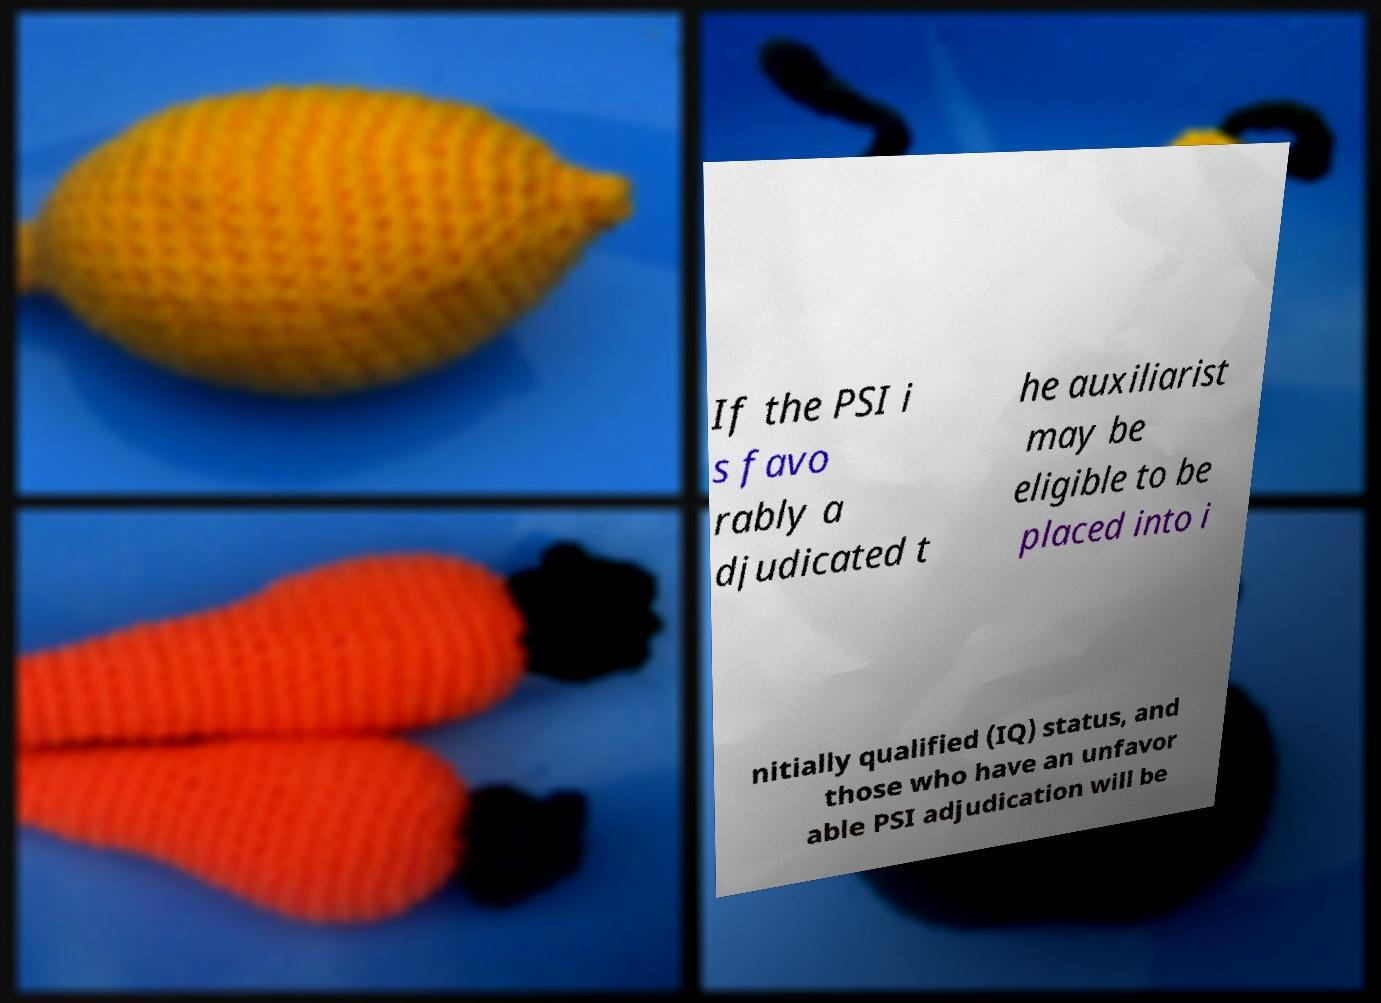Can you read and provide the text displayed in the image?This photo seems to have some interesting text. Can you extract and type it out for me? If the PSI i s favo rably a djudicated t he auxiliarist may be eligible to be placed into i nitially qualified (IQ) status, and those who have an unfavor able PSI adjudication will be 